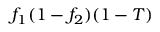<formula> <loc_0><loc_0><loc_500><loc_500>f _ { 1 } ( 1 - f _ { 2 } ) ( 1 - T )</formula> 